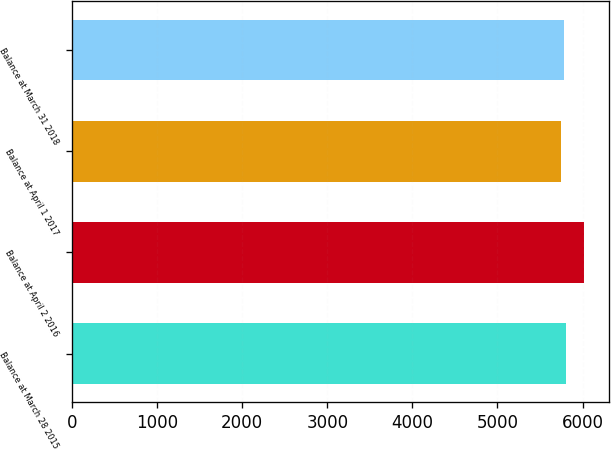Convert chart to OTSL. <chart><loc_0><loc_0><loc_500><loc_500><bar_chart><fcel>Balance at March 28 2015<fcel>Balance at April 2 2016<fcel>Balance at April 1 2017<fcel>Balance at March 31 2018<nl><fcel>5804.52<fcel>6015<fcel>5751.9<fcel>5778.21<nl></chart> 